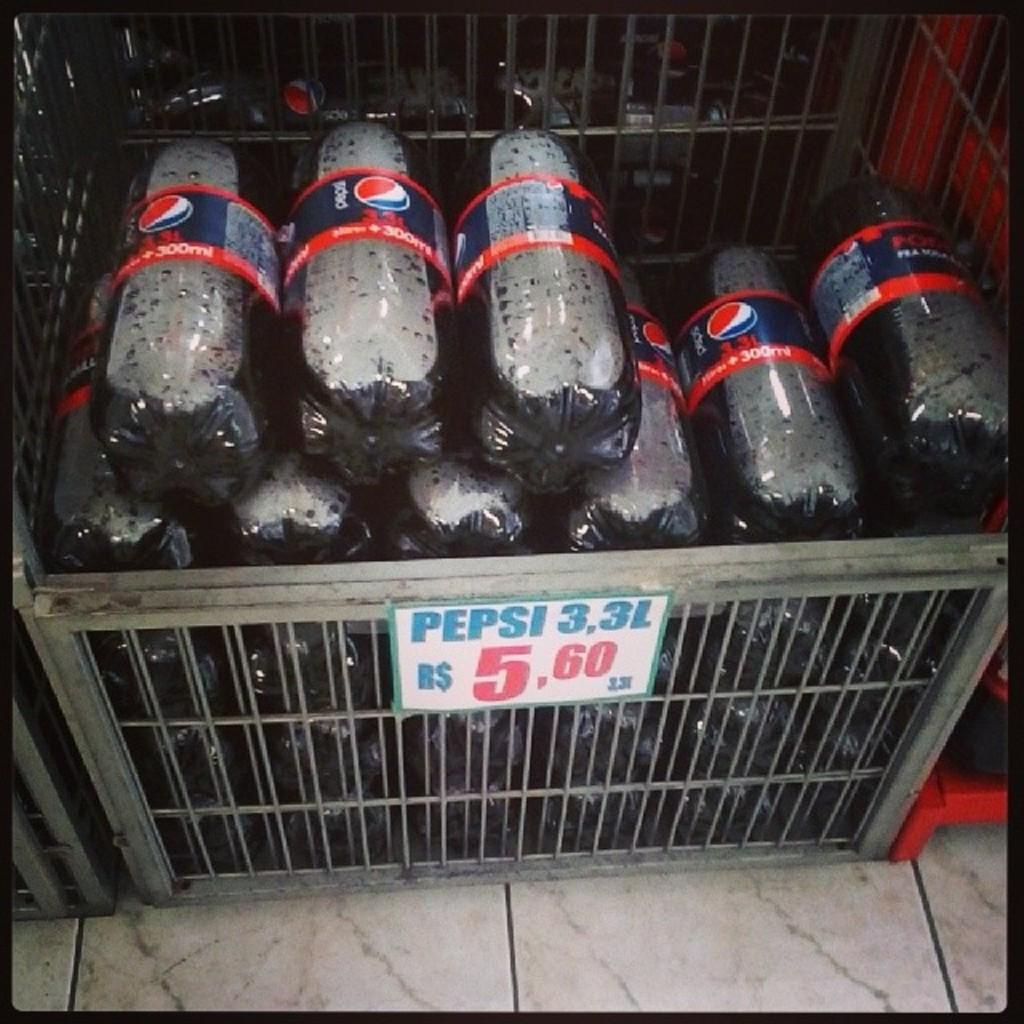What is the main object in the image? There is a box in the image. What is inside the box? Bottles are filled and placed inside the box. What type of sense does the zebra have in the image? There is no zebra present in the image, so it is not possible to determine what type of sense it might have. 